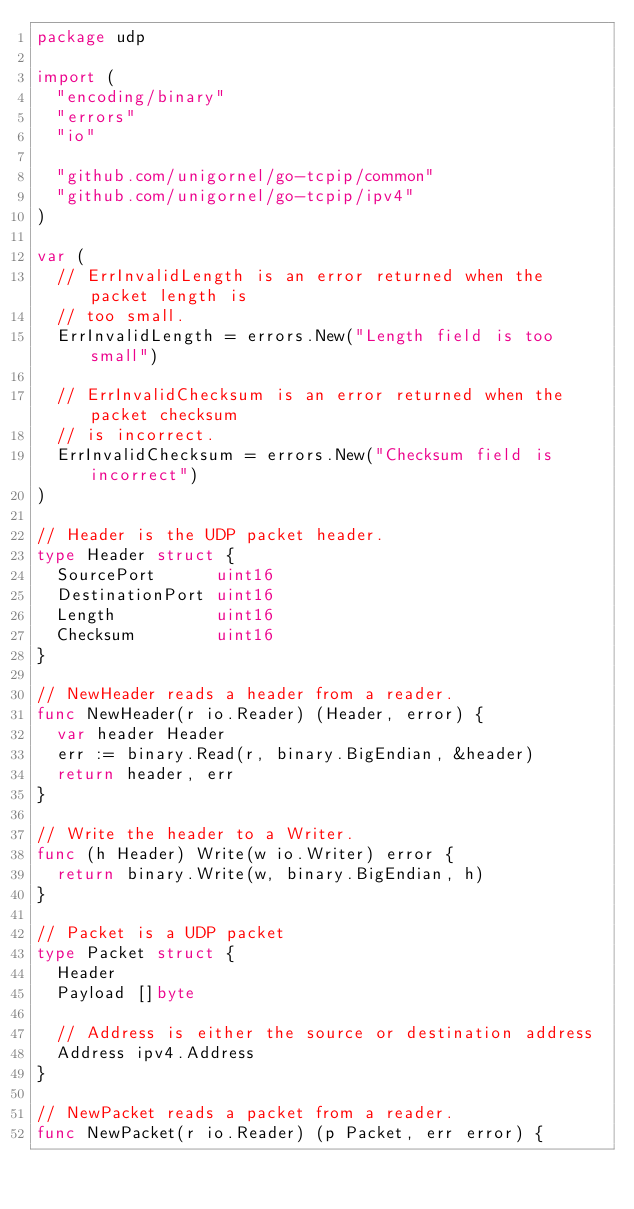<code> <loc_0><loc_0><loc_500><loc_500><_Go_>package udp

import (
	"encoding/binary"
	"errors"
	"io"

	"github.com/unigornel/go-tcpip/common"
	"github.com/unigornel/go-tcpip/ipv4"
)

var (
	// ErrInvalidLength is an error returned when the packet length is
	// too small.
	ErrInvalidLength = errors.New("Length field is too small")

	// ErrInvalidChecksum is an error returned when the packet checksum
	// is incorrect.
	ErrInvalidChecksum = errors.New("Checksum field is incorrect")
)

// Header is the UDP packet header.
type Header struct {
	SourcePort      uint16
	DestinationPort uint16
	Length          uint16
	Checksum        uint16
}

// NewHeader reads a header from a reader.
func NewHeader(r io.Reader) (Header, error) {
	var header Header
	err := binary.Read(r, binary.BigEndian, &header)
	return header, err
}

// Write the header to a Writer.
func (h Header) Write(w io.Writer) error {
	return binary.Write(w, binary.BigEndian, h)
}

// Packet is a UDP packet
type Packet struct {
	Header
	Payload []byte

	// Address is either the source or destination address
	Address ipv4.Address
}

// NewPacket reads a packet from a reader.
func NewPacket(r io.Reader) (p Packet, err error) {</code> 